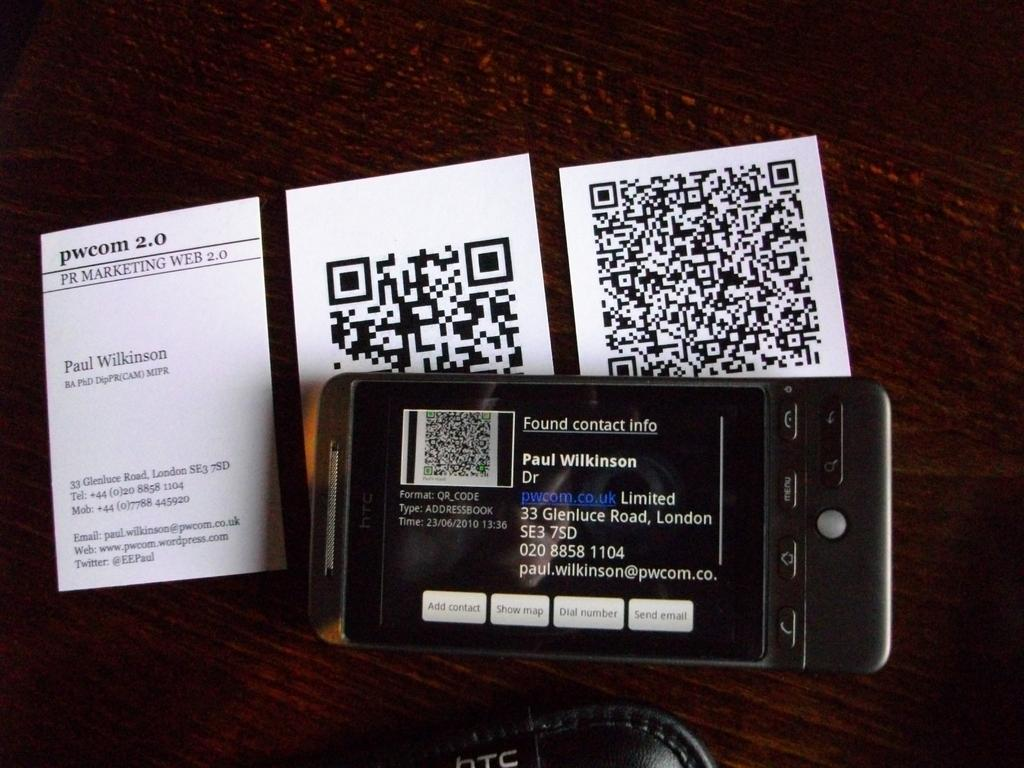<image>
Render a clear and concise summary of the photo. A camera that has a sticker that says Found contact info. 